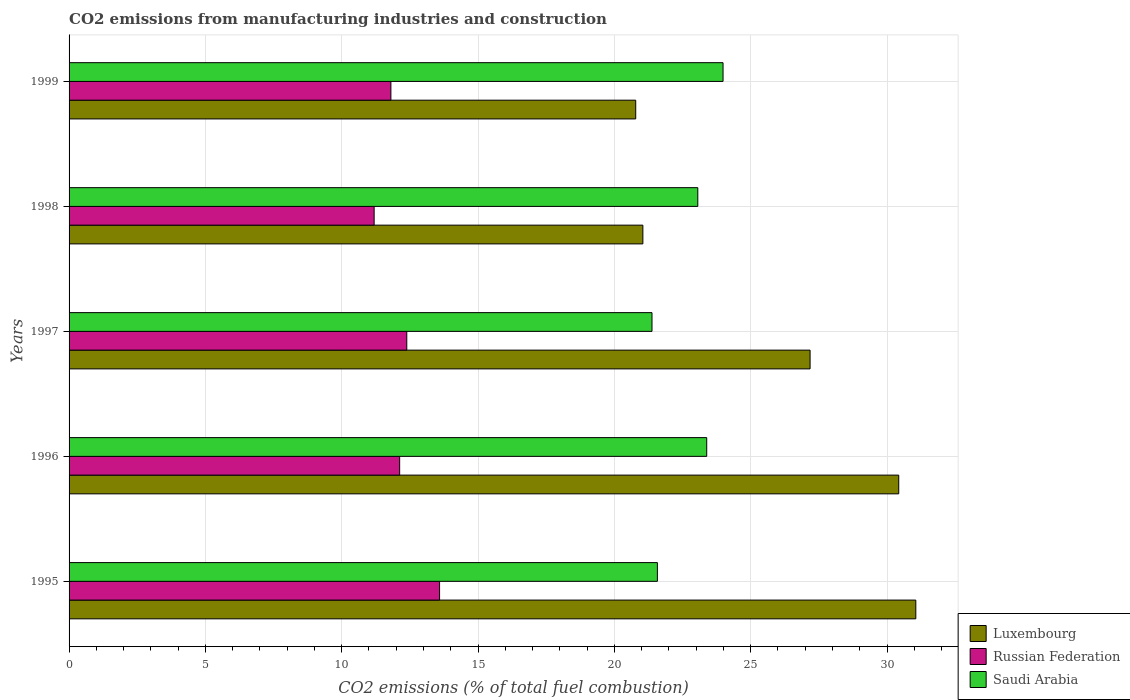How many different coloured bars are there?
Offer a very short reply. 3. How many groups of bars are there?
Offer a terse response. 5. Are the number of bars per tick equal to the number of legend labels?
Your answer should be compact. Yes. Are the number of bars on each tick of the Y-axis equal?
Ensure brevity in your answer.  Yes. How many bars are there on the 2nd tick from the top?
Your response must be concise. 3. What is the amount of CO2 emitted in Saudi Arabia in 1998?
Your answer should be very brief. 23.06. Across all years, what is the maximum amount of CO2 emitted in Saudi Arabia?
Your answer should be compact. 23.99. Across all years, what is the minimum amount of CO2 emitted in Luxembourg?
Provide a short and direct response. 20.78. In which year was the amount of CO2 emitted in Luxembourg maximum?
Your answer should be very brief. 1995. In which year was the amount of CO2 emitted in Luxembourg minimum?
Your response must be concise. 1999. What is the total amount of CO2 emitted in Luxembourg in the graph?
Make the answer very short. 130.49. What is the difference between the amount of CO2 emitted in Saudi Arabia in 1997 and that in 1999?
Offer a very short reply. -2.61. What is the difference between the amount of CO2 emitted in Saudi Arabia in 1996 and the amount of CO2 emitted in Luxembourg in 1999?
Give a very brief answer. 2.6. What is the average amount of CO2 emitted in Luxembourg per year?
Offer a very short reply. 26.1. In the year 1998, what is the difference between the amount of CO2 emitted in Saudi Arabia and amount of CO2 emitted in Russian Federation?
Give a very brief answer. 11.87. What is the ratio of the amount of CO2 emitted in Russian Federation in 1996 to that in 1998?
Give a very brief answer. 1.08. Is the amount of CO2 emitted in Russian Federation in 1997 less than that in 1998?
Provide a succinct answer. No. What is the difference between the highest and the second highest amount of CO2 emitted in Luxembourg?
Your answer should be compact. 0.63. What is the difference between the highest and the lowest amount of CO2 emitted in Luxembourg?
Offer a terse response. 10.27. In how many years, is the amount of CO2 emitted in Russian Federation greater than the average amount of CO2 emitted in Russian Federation taken over all years?
Your answer should be very brief. 2. Is the sum of the amount of CO2 emitted in Saudi Arabia in 1997 and 1998 greater than the maximum amount of CO2 emitted in Luxembourg across all years?
Provide a succinct answer. Yes. What does the 1st bar from the top in 1996 represents?
Your answer should be very brief. Saudi Arabia. What does the 1st bar from the bottom in 1996 represents?
Offer a very short reply. Luxembourg. Is it the case that in every year, the sum of the amount of CO2 emitted in Luxembourg and amount of CO2 emitted in Saudi Arabia is greater than the amount of CO2 emitted in Russian Federation?
Offer a terse response. Yes. How many bars are there?
Offer a terse response. 15. Does the graph contain any zero values?
Offer a very short reply. No. Where does the legend appear in the graph?
Your answer should be very brief. Bottom right. How many legend labels are there?
Provide a succinct answer. 3. What is the title of the graph?
Keep it short and to the point. CO2 emissions from manufacturing industries and construction. Does "Tunisia" appear as one of the legend labels in the graph?
Provide a succinct answer. No. What is the label or title of the X-axis?
Provide a succinct answer. CO2 emissions (% of total fuel combustion). What is the CO2 emissions (% of total fuel combustion) in Luxembourg in 1995?
Keep it short and to the point. 31.06. What is the CO2 emissions (% of total fuel combustion) in Russian Federation in 1995?
Your response must be concise. 13.59. What is the CO2 emissions (% of total fuel combustion) of Saudi Arabia in 1995?
Offer a very short reply. 21.58. What is the CO2 emissions (% of total fuel combustion) of Luxembourg in 1996?
Offer a terse response. 30.43. What is the CO2 emissions (% of total fuel combustion) in Russian Federation in 1996?
Make the answer very short. 12.12. What is the CO2 emissions (% of total fuel combustion) of Saudi Arabia in 1996?
Keep it short and to the point. 23.39. What is the CO2 emissions (% of total fuel combustion) of Luxembourg in 1997?
Offer a terse response. 27.18. What is the CO2 emissions (% of total fuel combustion) of Russian Federation in 1997?
Make the answer very short. 12.39. What is the CO2 emissions (% of total fuel combustion) in Saudi Arabia in 1997?
Provide a succinct answer. 21.38. What is the CO2 emissions (% of total fuel combustion) of Luxembourg in 1998?
Your answer should be very brief. 21.05. What is the CO2 emissions (% of total fuel combustion) in Russian Federation in 1998?
Offer a very short reply. 11.19. What is the CO2 emissions (% of total fuel combustion) in Saudi Arabia in 1998?
Your answer should be very brief. 23.06. What is the CO2 emissions (% of total fuel combustion) in Luxembourg in 1999?
Your response must be concise. 20.78. What is the CO2 emissions (% of total fuel combustion) in Russian Federation in 1999?
Make the answer very short. 11.8. What is the CO2 emissions (% of total fuel combustion) of Saudi Arabia in 1999?
Give a very brief answer. 23.99. Across all years, what is the maximum CO2 emissions (% of total fuel combustion) of Luxembourg?
Your answer should be compact. 31.06. Across all years, what is the maximum CO2 emissions (% of total fuel combustion) of Russian Federation?
Provide a succinct answer. 13.59. Across all years, what is the maximum CO2 emissions (% of total fuel combustion) of Saudi Arabia?
Your response must be concise. 23.99. Across all years, what is the minimum CO2 emissions (% of total fuel combustion) in Luxembourg?
Offer a terse response. 20.78. Across all years, what is the minimum CO2 emissions (% of total fuel combustion) in Russian Federation?
Make the answer very short. 11.19. Across all years, what is the minimum CO2 emissions (% of total fuel combustion) of Saudi Arabia?
Offer a terse response. 21.38. What is the total CO2 emissions (% of total fuel combustion) in Luxembourg in the graph?
Provide a succinct answer. 130.49. What is the total CO2 emissions (% of total fuel combustion) in Russian Federation in the graph?
Offer a very short reply. 61.09. What is the total CO2 emissions (% of total fuel combustion) of Saudi Arabia in the graph?
Keep it short and to the point. 113.39. What is the difference between the CO2 emissions (% of total fuel combustion) in Luxembourg in 1995 and that in 1996?
Your response must be concise. 0.63. What is the difference between the CO2 emissions (% of total fuel combustion) in Russian Federation in 1995 and that in 1996?
Give a very brief answer. 1.46. What is the difference between the CO2 emissions (% of total fuel combustion) of Saudi Arabia in 1995 and that in 1996?
Your answer should be compact. -1.81. What is the difference between the CO2 emissions (% of total fuel combustion) of Luxembourg in 1995 and that in 1997?
Your answer should be compact. 3.88. What is the difference between the CO2 emissions (% of total fuel combustion) of Russian Federation in 1995 and that in 1997?
Your answer should be compact. 1.2. What is the difference between the CO2 emissions (% of total fuel combustion) in Saudi Arabia in 1995 and that in 1997?
Your answer should be very brief. 0.2. What is the difference between the CO2 emissions (% of total fuel combustion) of Luxembourg in 1995 and that in 1998?
Ensure brevity in your answer.  10.01. What is the difference between the CO2 emissions (% of total fuel combustion) of Russian Federation in 1995 and that in 1998?
Ensure brevity in your answer.  2.4. What is the difference between the CO2 emissions (% of total fuel combustion) in Saudi Arabia in 1995 and that in 1998?
Give a very brief answer. -1.48. What is the difference between the CO2 emissions (% of total fuel combustion) in Luxembourg in 1995 and that in 1999?
Keep it short and to the point. 10.27. What is the difference between the CO2 emissions (% of total fuel combustion) in Russian Federation in 1995 and that in 1999?
Provide a succinct answer. 1.79. What is the difference between the CO2 emissions (% of total fuel combustion) in Saudi Arabia in 1995 and that in 1999?
Your response must be concise. -2.41. What is the difference between the CO2 emissions (% of total fuel combustion) in Luxembourg in 1996 and that in 1997?
Give a very brief answer. 3.25. What is the difference between the CO2 emissions (% of total fuel combustion) in Russian Federation in 1996 and that in 1997?
Offer a very short reply. -0.26. What is the difference between the CO2 emissions (% of total fuel combustion) of Saudi Arabia in 1996 and that in 1997?
Your answer should be very brief. 2.01. What is the difference between the CO2 emissions (% of total fuel combustion) in Luxembourg in 1996 and that in 1998?
Offer a very short reply. 9.38. What is the difference between the CO2 emissions (% of total fuel combustion) in Russian Federation in 1996 and that in 1998?
Keep it short and to the point. 0.94. What is the difference between the CO2 emissions (% of total fuel combustion) of Saudi Arabia in 1996 and that in 1998?
Your response must be concise. 0.33. What is the difference between the CO2 emissions (% of total fuel combustion) in Luxembourg in 1996 and that in 1999?
Give a very brief answer. 9.65. What is the difference between the CO2 emissions (% of total fuel combustion) of Russian Federation in 1996 and that in 1999?
Make the answer very short. 0.32. What is the difference between the CO2 emissions (% of total fuel combustion) of Saudi Arabia in 1996 and that in 1999?
Give a very brief answer. -0.6. What is the difference between the CO2 emissions (% of total fuel combustion) of Luxembourg in 1997 and that in 1998?
Your response must be concise. 6.13. What is the difference between the CO2 emissions (% of total fuel combustion) of Russian Federation in 1997 and that in 1998?
Your response must be concise. 1.2. What is the difference between the CO2 emissions (% of total fuel combustion) of Saudi Arabia in 1997 and that in 1998?
Keep it short and to the point. -1.68. What is the difference between the CO2 emissions (% of total fuel combustion) in Luxembourg in 1997 and that in 1999?
Provide a succinct answer. 6.4. What is the difference between the CO2 emissions (% of total fuel combustion) in Russian Federation in 1997 and that in 1999?
Offer a terse response. 0.58. What is the difference between the CO2 emissions (% of total fuel combustion) of Saudi Arabia in 1997 and that in 1999?
Give a very brief answer. -2.61. What is the difference between the CO2 emissions (% of total fuel combustion) of Luxembourg in 1998 and that in 1999?
Your response must be concise. 0.26. What is the difference between the CO2 emissions (% of total fuel combustion) in Russian Federation in 1998 and that in 1999?
Your answer should be compact. -0.61. What is the difference between the CO2 emissions (% of total fuel combustion) in Saudi Arabia in 1998 and that in 1999?
Offer a terse response. -0.93. What is the difference between the CO2 emissions (% of total fuel combustion) in Luxembourg in 1995 and the CO2 emissions (% of total fuel combustion) in Russian Federation in 1996?
Offer a very short reply. 18.93. What is the difference between the CO2 emissions (% of total fuel combustion) in Luxembourg in 1995 and the CO2 emissions (% of total fuel combustion) in Saudi Arabia in 1996?
Offer a terse response. 7.67. What is the difference between the CO2 emissions (% of total fuel combustion) in Russian Federation in 1995 and the CO2 emissions (% of total fuel combustion) in Saudi Arabia in 1996?
Your answer should be very brief. -9.8. What is the difference between the CO2 emissions (% of total fuel combustion) in Luxembourg in 1995 and the CO2 emissions (% of total fuel combustion) in Russian Federation in 1997?
Offer a very short reply. 18.67. What is the difference between the CO2 emissions (% of total fuel combustion) of Luxembourg in 1995 and the CO2 emissions (% of total fuel combustion) of Saudi Arabia in 1997?
Offer a terse response. 9.68. What is the difference between the CO2 emissions (% of total fuel combustion) in Russian Federation in 1995 and the CO2 emissions (% of total fuel combustion) in Saudi Arabia in 1997?
Your answer should be very brief. -7.79. What is the difference between the CO2 emissions (% of total fuel combustion) of Luxembourg in 1995 and the CO2 emissions (% of total fuel combustion) of Russian Federation in 1998?
Provide a succinct answer. 19.87. What is the difference between the CO2 emissions (% of total fuel combustion) in Luxembourg in 1995 and the CO2 emissions (% of total fuel combustion) in Saudi Arabia in 1998?
Offer a terse response. 8. What is the difference between the CO2 emissions (% of total fuel combustion) in Russian Federation in 1995 and the CO2 emissions (% of total fuel combustion) in Saudi Arabia in 1998?
Provide a short and direct response. -9.47. What is the difference between the CO2 emissions (% of total fuel combustion) of Luxembourg in 1995 and the CO2 emissions (% of total fuel combustion) of Russian Federation in 1999?
Give a very brief answer. 19.25. What is the difference between the CO2 emissions (% of total fuel combustion) of Luxembourg in 1995 and the CO2 emissions (% of total fuel combustion) of Saudi Arabia in 1999?
Keep it short and to the point. 7.07. What is the difference between the CO2 emissions (% of total fuel combustion) in Russian Federation in 1995 and the CO2 emissions (% of total fuel combustion) in Saudi Arabia in 1999?
Provide a short and direct response. -10.4. What is the difference between the CO2 emissions (% of total fuel combustion) of Luxembourg in 1996 and the CO2 emissions (% of total fuel combustion) of Russian Federation in 1997?
Your answer should be very brief. 18.04. What is the difference between the CO2 emissions (% of total fuel combustion) in Luxembourg in 1996 and the CO2 emissions (% of total fuel combustion) in Saudi Arabia in 1997?
Give a very brief answer. 9.05. What is the difference between the CO2 emissions (% of total fuel combustion) in Russian Federation in 1996 and the CO2 emissions (% of total fuel combustion) in Saudi Arabia in 1997?
Your response must be concise. -9.26. What is the difference between the CO2 emissions (% of total fuel combustion) in Luxembourg in 1996 and the CO2 emissions (% of total fuel combustion) in Russian Federation in 1998?
Ensure brevity in your answer.  19.24. What is the difference between the CO2 emissions (% of total fuel combustion) of Luxembourg in 1996 and the CO2 emissions (% of total fuel combustion) of Saudi Arabia in 1998?
Keep it short and to the point. 7.37. What is the difference between the CO2 emissions (% of total fuel combustion) of Russian Federation in 1996 and the CO2 emissions (% of total fuel combustion) of Saudi Arabia in 1998?
Your answer should be compact. -10.94. What is the difference between the CO2 emissions (% of total fuel combustion) of Luxembourg in 1996 and the CO2 emissions (% of total fuel combustion) of Russian Federation in 1999?
Keep it short and to the point. 18.63. What is the difference between the CO2 emissions (% of total fuel combustion) of Luxembourg in 1996 and the CO2 emissions (% of total fuel combustion) of Saudi Arabia in 1999?
Your answer should be very brief. 6.44. What is the difference between the CO2 emissions (% of total fuel combustion) in Russian Federation in 1996 and the CO2 emissions (% of total fuel combustion) in Saudi Arabia in 1999?
Your response must be concise. -11.86. What is the difference between the CO2 emissions (% of total fuel combustion) in Luxembourg in 1997 and the CO2 emissions (% of total fuel combustion) in Russian Federation in 1998?
Provide a succinct answer. 15.99. What is the difference between the CO2 emissions (% of total fuel combustion) in Luxembourg in 1997 and the CO2 emissions (% of total fuel combustion) in Saudi Arabia in 1998?
Keep it short and to the point. 4.12. What is the difference between the CO2 emissions (% of total fuel combustion) in Russian Federation in 1997 and the CO2 emissions (% of total fuel combustion) in Saudi Arabia in 1998?
Keep it short and to the point. -10.67. What is the difference between the CO2 emissions (% of total fuel combustion) in Luxembourg in 1997 and the CO2 emissions (% of total fuel combustion) in Russian Federation in 1999?
Your answer should be very brief. 15.37. What is the difference between the CO2 emissions (% of total fuel combustion) in Luxembourg in 1997 and the CO2 emissions (% of total fuel combustion) in Saudi Arabia in 1999?
Your answer should be compact. 3.19. What is the difference between the CO2 emissions (% of total fuel combustion) of Russian Federation in 1997 and the CO2 emissions (% of total fuel combustion) of Saudi Arabia in 1999?
Your answer should be very brief. -11.6. What is the difference between the CO2 emissions (% of total fuel combustion) in Luxembourg in 1998 and the CO2 emissions (% of total fuel combustion) in Russian Federation in 1999?
Your answer should be compact. 9.24. What is the difference between the CO2 emissions (% of total fuel combustion) of Luxembourg in 1998 and the CO2 emissions (% of total fuel combustion) of Saudi Arabia in 1999?
Give a very brief answer. -2.94. What is the difference between the CO2 emissions (% of total fuel combustion) in Russian Federation in 1998 and the CO2 emissions (% of total fuel combustion) in Saudi Arabia in 1999?
Make the answer very short. -12.8. What is the average CO2 emissions (% of total fuel combustion) of Luxembourg per year?
Offer a very short reply. 26.1. What is the average CO2 emissions (% of total fuel combustion) in Russian Federation per year?
Your response must be concise. 12.22. What is the average CO2 emissions (% of total fuel combustion) of Saudi Arabia per year?
Offer a very short reply. 22.68. In the year 1995, what is the difference between the CO2 emissions (% of total fuel combustion) of Luxembourg and CO2 emissions (% of total fuel combustion) of Russian Federation?
Provide a succinct answer. 17.47. In the year 1995, what is the difference between the CO2 emissions (% of total fuel combustion) in Luxembourg and CO2 emissions (% of total fuel combustion) in Saudi Arabia?
Offer a very short reply. 9.48. In the year 1995, what is the difference between the CO2 emissions (% of total fuel combustion) of Russian Federation and CO2 emissions (% of total fuel combustion) of Saudi Arabia?
Ensure brevity in your answer.  -7.99. In the year 1996, what is the difference between the CO2 emissions (% of total fuel combustion) in Luxembourg and CO2 emissions (% of total fuel combustion) in Russian Federation?
Offer a terse response. 18.3. In the year 1996, what is the difference between the CO2 emissions (% of total fuel combustion) in Luxembourg and CO2 emissions (% of total fuel combustion) in Saudi Arabia?
Offer a terse response. 7.04. In the year 1996, what is the difference between the CO2 emissions (% of total fuel combustion) of Russian Federation and CO2 emissions (% of total fuel combustion) of Saudi Arabia?
Provide a succinct answer. -11.26. In the year 1997, what is the difference between the CO2 emissions (% of total fuel combustion) of Luxembourg and CO2 emissions (% of total fuel combustion) of Russian Federation?
Keep it short and to the point. 14.79. In the year 1997, what is the difference between the CO2 emissions (% of total fuel combustion) of Luxembourg and CO2 emissions (% of total fuel combustion) of Saudi Arabia?
Offer a terse response. 5.8. In the year 1997, what is the difference between the CO2 emissions (% of total fuel combustion) of Russian Federation and CO2 emissions (% of total fuel combustion) of Saudi Arabia?
Provide a short and direct response. -8.99. In the year 1998, what is the difference between the CO2 emissions (% of total fuel combustion) of Luxembourg and CO2 emissions (% of total fuel combustion) of Russian Federation?
Your answer should be compact. 9.86. In the year 1998, what is the difference between the CO2 emissions (% of total fuel combustion) in Luxembourg and CO2 emissions (% of total fuel combustion) in Saudi Arabia?
Provide a succinct answer. -2.01. In the year 1998, what is the difference between the CO2 emissions (% of total fuel combustion) in Russian Federation and CO2 emissions (% of total fuel combustion) in Saudi Arabia?
Ensure brevity in your answer.  -11.87. In the year 1999, what is the difference between the CO2 emissions (% of total fuel combustion) of Luxembourg and CO2 emissions (% of total fuel combustion) of Russian Federation?
Provide a short and direct response. 8.98. In the year 1999, what is the difference between the CO2 emissions (% of total fuel combustion) in Luxembourg and CO2 emissions (% of total fuel combustion) in Saudi Arabia?
Your answer should be very brief. -3.2. In the year 1999, what is the difference between the CO2 emissions (% of total fuel combustion) of Russian Federation and CO2 emissions (% of total fuel combustion) of Saudi Arabia?
Your answer should be very brief. -12.18. What is the ratio of the CO2 emissions (% of total fuel combustion) in Luxembourg in 1995 to that in 1996?
Provide a short and direct response. 1.02. What is the ratio of the CO2 emissions (% of total fuel combustion) of Russian Federation in 1995 to that in 1996?
Offer a very short reply. 1.12. What is the ratio of the CO2 emissions (% of total fuel combustion) in Saudi Arabia in 1995 to that in 1996?
Keep it short and to the point. 0.92. What is the ratio of the CO2 emissions (% of total fuel combustion) of Luxembourg in 1995 to that in 1997?
Give a very brief answer. 1.14. What is the ratio of the CO2 emissions (% of total fuel combustion) of Russian Federation in 1995 to that in 1997?
Ensure brevity in your answer.  1.1. What is the ratio of the CO2 emissions (% of total fuel combustion) of Saudi Arabia in 1995 to that in 1997?
Provide a short and direct response. 1.01. What is the ratio of the CO2 emissions (% of total fuel combustion) in Luxembourg in 1995 to that in 1998?
Ensure brevity in your answer.  1.48. What is the ratio of the CO2 emissions (% of total fuel combustion) of Russian Federation in 1995 to that in 1998?
Give a very brief answer. 1.21. What is the ratio of the CO2 emissions (% of total fuel combustion) in Saudi Arabia in 1995 to that in 1998?
Your response must be concise. 0.94. What is the ratio of the CO2 emissions (% of total fuel combustion) of Luxembourg in 1995 to that in 1999?
Offer a very short reply. 1.49. What is the ratio of the CO2 emissions (% of total fuel combustion) in Russian Federation in 1995 to that in 1999?
Your answer should be very brief. 1.15. What is the ratio of the CO2 emissions (% of total fuel combustion) in Saudi Arabia in 1995 to that in 1999?
Your answer should be very brief. 0.9. What is the ratio of the CO2 emissions (% of total fuel combustion) in Luxembourg in 1996 to that in 1997?
Your answer should be very brief. 1.12. What is the ratio of the CO2 emissions (% of total fuel combustion) of Russian Federation in 1996 to that in 1997?
Make the answer very short. 0.98. What is the ratio of the CO2 emissions (% of total fuel combustion) of Saudi Arabia in 1996 to that in 1997?
Provide a short and direct response. 1.09. What is the ratio of the CO2 emissions (% of total fuel combustion) of Luxembourg in 1996 to that in 1998?
Keep it short and to the point. 1.45. What is the ratio of the CO2 emissions (% of total fuel combustion) of Russian Federation in 1996 to that in 1998?
Ensure brevity in your answer.  1.08. What is the ratio of the CO2 emissions (% of total fuel combustion) of Saudi Arabia in 1996 to that in 1998?
Keep it short and to the point. 1.01. What is the ratio of the CO2 emissions (% of total fuel combustion) of Luxembourg in 1996 to that in 1999?
Your response must be concise. 1.46. What is the ratio of the CO2 emissions (% of total fuel combustion) of Russian Federation in 1996 to that in 1999?
Make the answer very short. 1.03. What is the ratio of the CO2 emissions (% of total fuel combustion) of Luxembourg in 1997 to that in 1998?
Your response must be concise. 1.29. What is the ratio of the CO2 emissions (% of total fuel combustion) of Russian Federation in 1997 to that in 1998?
Your response must be concise. 1.11. What is the ratio of the CO2 emissions (% of total fuel combustion) in Saudi Arabia in 1997 to that in 1998?
Your answer should be very brief. 0.93. What is the ratio of the CO2 emissions (% of total fuel combustion) of Luxembourg in 1997 to that in 1999?
Provide a succinct answer. 1.31. What is the ratio of the CO2 emissions (% of total fuel combustion) in Russian Federation in 1997 to that in 1999?
Your response must be concise. 1.05. What is the ratio of the CO2 emissions (% of total fuel combustion) of Saudi Arabia in 1997 to that in 1999?
Your response must be concise. 0.89. What is the ratio of the CO2 emissions (% of total fuel combustion) of Luxembourg in 1998 to that in 1999?
Provide a succinct answer. 1.01. What is the ratio of the CO2 emissions (% of total fuel combustion) of Russian Federation in 1998 to that in 1999?
Your response must be concise. 0.95. What is the ratio of the CO2 emissions (% of total fuel combustion) of Saudi Arabia in 1998 to that in 1999?
Your answer should be very brief. 0.96. What is the difference between the highest and the second highest CO2 emissions (% of total fuel combustion) of Luxembourg?
Make the answer very short. 0.63. What is the difference between the highest and the second highest CO2 emissions (% of total fuel combustion) in Russian Federation?
Keep it short and to the point. 1.2. What is the difference between the highest and the second highest CO2 emissions (% of total fuel combustion) of Saudi Arabia?
Offer a very short reply. 0.6. What is the difference between the highest and the lowest CO2 emissions (% of total fuel combustion) of Luxembourg?
Offer a terse response. 10.27. What is the difference between the highest and the lowest CO2 emissions (% of total fuel combustion) of Russian Federation?
Provide a succinct answer. 2.4. What is the difference between the highest and the lowest CO2 emissions (% of total fuel combustion) of Saudi Arabia?
Provide a short and direct response. 2.61. 